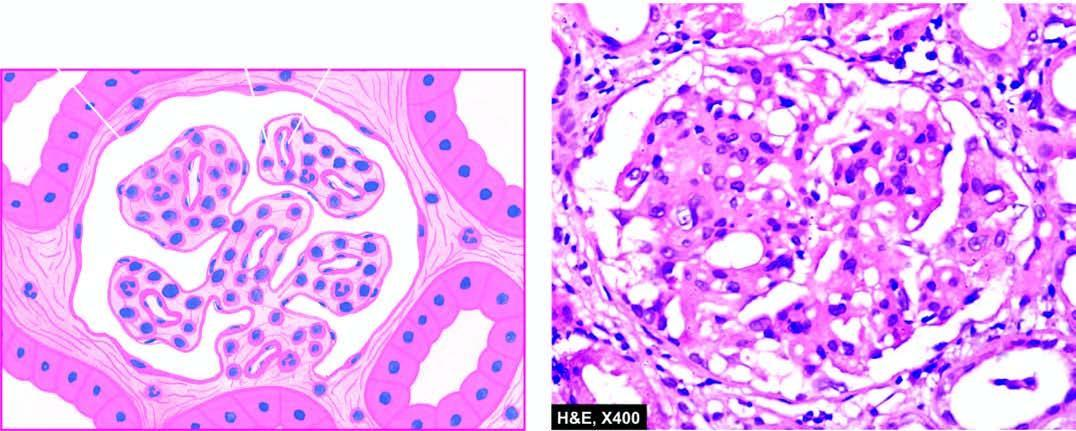what is there of the gbm?
Answer the question using a single word or phrase. Widespread thickening 